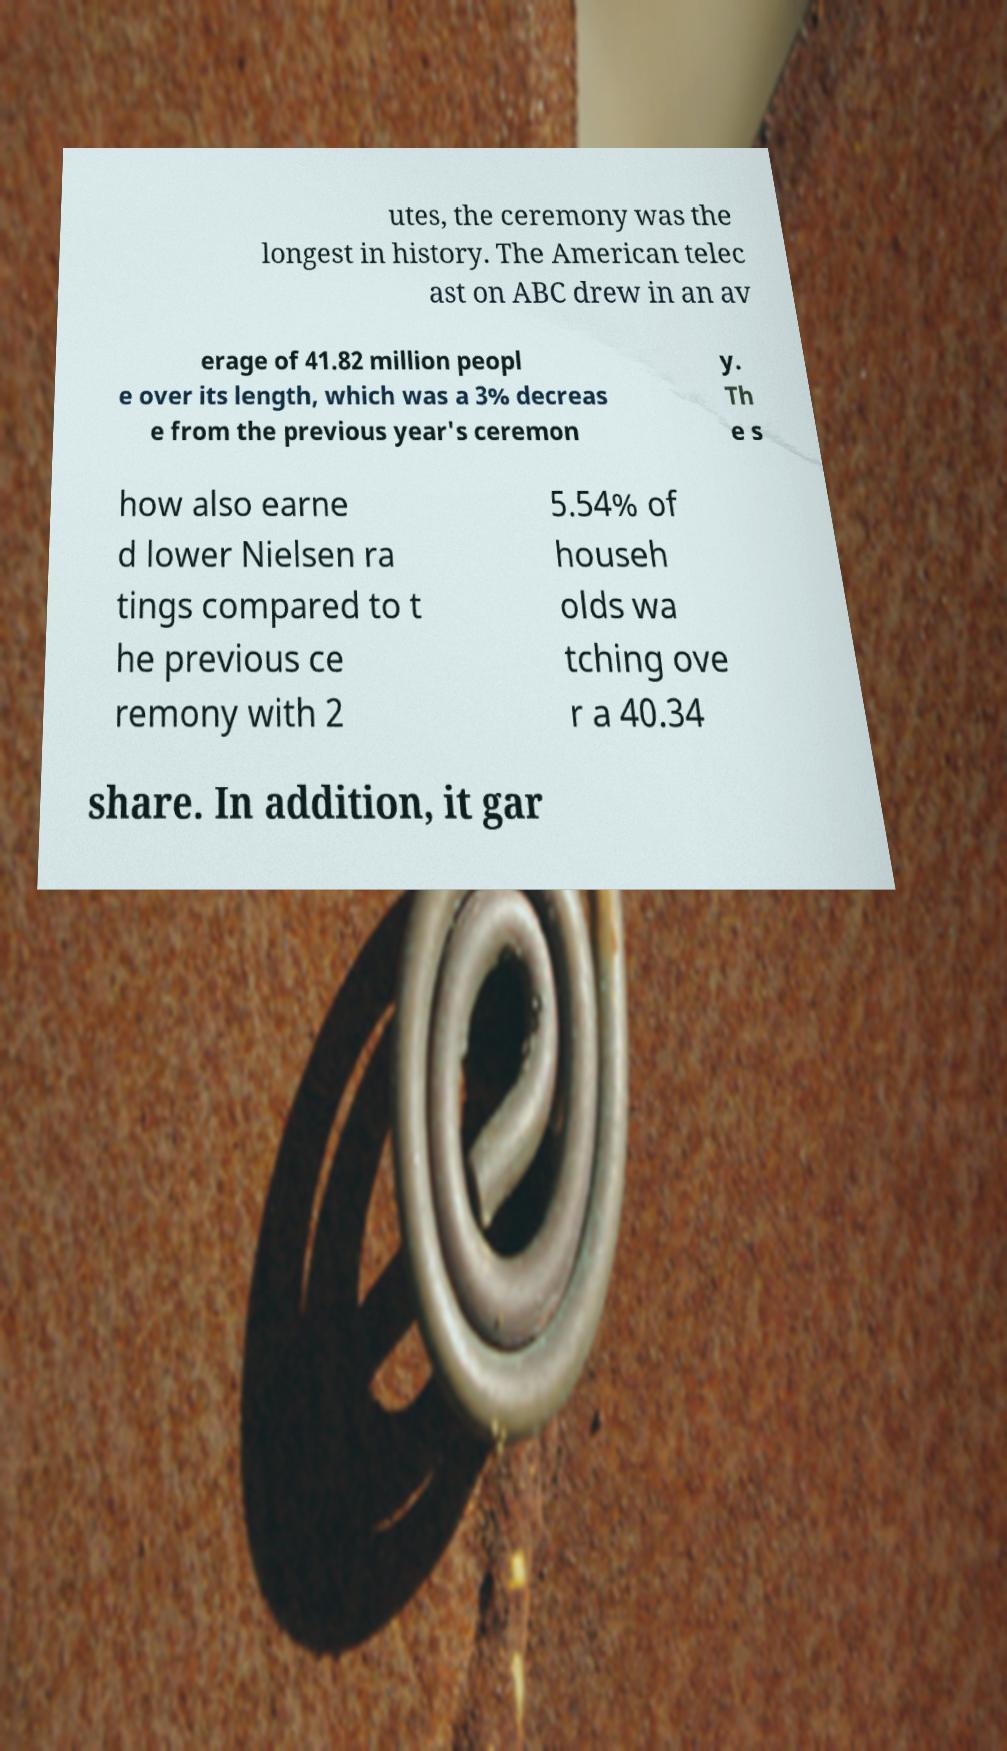There's text embedded in this image that I need extracted. Can you transcribe it verbatim? utes, the ceremony was the longest in history. The American telec ast on ABC drew in an av erage of 41.82 million peopl e over its length, which was a 3% decreas e from the previous year's ceremon y. Th e s how also earne d lower Nielsen ra tings compared to t he previous ce remony with 2 5.54% of househ olds wa tching ove r a 40.34 share. In addition, it gar 